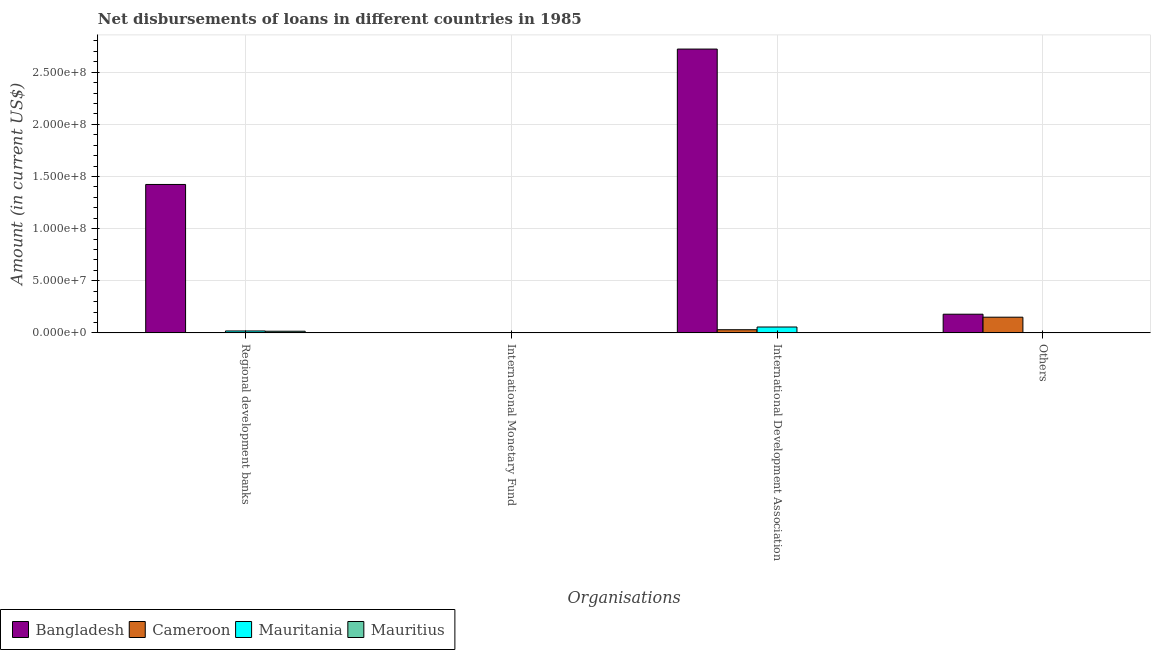How many different coloured bars are there?
Offer a very short reply. 4. Are the number of bars per tick equal to the number of legend labels?
Ensure brevity in your answer.  No. Are the number of bars on each tick of the X-axis equal?
Provide a short and direct response. No. What is the label of the 3rd group of bars from the left?
Offer a very short reply. International Development Association. What is the amount of loan disimbursed by international monetary fund in Mauritius?
Offer a very short reply. 0. Across all countries, what is the maximum amount of loan disimbursed by other organisations?
Your response must be concise. 1.79e+07. What is the total amount of loan disimbursed by international development association in the graph?
Your answer should be compact. 2.81e+08. What is the difference between the amount of loan disimbursed by regional development banks in Cameroon and that in Mauritania?
Your answer should be very brief. -1.83e+06. What is the difference between the amount of loan disimbursed by international monetary fund in Bangladesh and the amount of loan disimbursed by international development association in Mauritania?
Provide a succinct answer. -5.62e+06. What is the average amount of loan disimbursed by other organisations per country?
Provide a succinct answer. 8.23e+06. What is the difference between the amount of loan disimbursed by international development association and amount of loan disimbursed by regional development banks in Bangladesh?
Your answer should be very brief. 1.30e+08. What is the ratio of the amount of loan disimbursed by regional development banks in Cameroon to that in Mauritius?
Make the answer very short. 0. Is the amount of loan disimbursed by regional development banks in Bangladesh less than that in Mauritania?
Offer a very short reply. No. What is the difference between the highest and the second highest amount of loan disimbursed by regional development banks?
Provide a short and direct response. 1.41e+08. What is the difference between the highest and the lowest amount of loan disimbursed by regional development banks?
Give a very brief answer. 1.42e+08. Is it the case that in every country, the sum of the amount of loan disimbursed by regional development banks and amount of loan disimbursed by international monetary fund is greater than the amount of loan disimbursed by international development association?
Give a very brief answer. No. Are all the bars in the graph horizontal?
Your response must be concise. No. What is the difference between two consecutive major ticks on the Y-axis?
Give a very brief answer. 5.00e+07. Does the graph contain any zero values?
Your answer should be very brief. Yes. Does the graph contain grids?
Your answer should be compact. Yes. Where does the legend appear in the graph?
Your answer should be very brief. Bottom left. How many legend labels are there?
Make the answer very short. 4. How are the legend labels stacked?
Your answer should be compact. Horizontal. What is the title of the graph?
Provide a succinct answer. Net disbursements of loans in different countries in 1985. Does "Bulgaria" appear as one of the legend labels in the graph?
Your answer should be very brief. No. What is the label or title of the X-axis?
Your answer should be compact. Organisations. What is the label or title of the Y-axis?
Keep it short and to the point. Amount (in current US$). What is the Amount (in current US$) in Bangladesh in Regional development banks?
Offer a very short reply. 1.42e+08. What is the Amount (in current US$) in Cameroon in Regional development banks?
Your answer should be compact. 5000. What is the Amount (in current US$) of Mauritania in Regional development banks?
Your response must be concise. 1.83e+06. What is the Amount (in current US$) in Mauritius in Regional development banks?
Provide a succinct answer. 1.57e+06. What is the Amount (in current US$) in Bangladesh in International Development Association?
Make the answer very short. 2.72e+08. What is the Amount (in current US$) of Cameroon in International Development Association?
Make the answer very short. 3.02e+06. What is the Amount (in current US$) in Mauritania in International Development Association?
Offer a very short reply. 5.62e+06. What is the Amount (in current US$) in Bangladesh in Others?
Keep it short and to the point. 1.79e+07. What is the Amount (in current US$) in Cameroon in Others?
Keep it short and to the point. 1.50e+07. What is the Amount (in current US$) of Mauritius in Others?
Offer a very short reply. 0. Across all Organisations, what is the maximum Amount (in current US$) in Bangladesh?
Make the answer very short. 2.72e+08. Across all Organisations, what is the maximum Amount (in current US$) in Cameroon?
Give a very brief answer. 1.50e+07. Across all Organisations, what is the maximum Amount (in current US$) of Mauritania?
Provide a short and direct response. 5.62e+06. Across all Organisations, what is the maximum Amount (in current US$) in Mauritius?
Keep it short and to the point. 1.57e+06. Across all Organisations, what is the minimum Amount (in current US$) of Bangladesh?
Your answer should be compact. 0. Across all Organisations, what is the minimum Amount (in current US$) of Mauritius?
Offer a terse response. 0. What is the total Amount (in current US$) in Bangladesh in the graph?
Make the answer very short. 4.32e+08. What is the total Amount (in current US$) of Cameroon in the graph?
Keep it short and to the point. 1.81e+07. What is the total Amount (in current US$) of Mauritania in the graph?
Your answer should be compact. 7.45e+06. What is the total Amount (in current US$) of Mauritius in the graph?
Provide a succinct answer. 1.57e+06. What is the difference between the Amount (in current US$) in Bangladesh in Regional development banks and that in International Development Association?
Your response must be concise. -1.30e+08. What is the difference between the Amount (in current US$) of Cameroon in Regional development banks and that in International Development Association?
Your response must be concise. -3.01e+06. What is the difference between the Amount (in current US$) in Mauritania in Regional development banks and that in International Development Association?
Your answer should be compact. -3.78e+06. What is the difference between the Amount (in current US$) of Bangladesh in Regional development banks and that in Others?
Give a very brief answer. 1.24e+08. What is the difference between the Amount (in current US$) in Cameroon in Regional development banks and that in Others?
Provide a succinct answer. -1.50e+07. What is the difference between the Amount (in current US$) in Bangladesh in International Development Association and that in Others?
Provide a short and direct response. 2.54e+08. What is the difference between the Amount (in current US$) in Cameroon in International Development Association and that in Others?
Offer a very short reply. -1.20e+07. What is the difference between the Amount (in current US$) in Bangladesh in Regional development banks and the Amount (in current US$) in Cameroon in International Development Association?
Give a very brief answer. 1.39e+08. What is the difference between the Amount (in current US$) in Bangladesh in Regional development banks and the Amount (in current US$) in Mauritania in International Development Association?
Provide a succinct answer. 1.37e+08. What is the difference between the Amount (in current US$) of Cameroon in Regional development banks and the Amount (in current US$) of Mauritania in International Development Association?
Make the answer very short. -5.61e+06. What is the difference between the Amount (in current US$) of Bangladesh in Regional development banks and the Amount (in current US$) of Cameroon in Others?
Give a very brief answer. 1.27e+08. What is the difference between the Amount (in current US$) in Bangladesh in International Development Association and the Amount (in current US$) in Cameroon in Others?
Ensure brevity in your answer.  2.57e+08. What is the average Amount (in current US$) in Bangladesh per Organisations?
Your answer should be very brief. 1.08e+08. What is the average Amount (in current US$) of Cameroon per Organisations?
Your answer should be very brief. 4.51e+06. What is the average Amount (in current US$) of Mauritania per Organisations?
Provide a short and direct response. 1.86e+06. What is the average Amount (in current US$) of Mauritius per Organisations?
Your answer should be very brief. 3.92e+05. What is the difference between the Amount (in current US$) of Bangladesh and Amount (in current US$) of Cameroon in Regional development banks?
Give a very brief answer. 1.42e+08. What is the difference between the Amount (in current US$) in Bangladesh and Amount (in current US$) in Mauritania in Regional development banks?
Keep it short and to the point. 1.41e+08. What is the difference between the Amount (in current US$) of Bangladesh and Amount (in current US$) of Mauritius in Regional development banks?
Ensure brevity in your answer.  1.41e+08. What is the difference between the Amount (in current US$) in Cameroon and Amount (in current US$) in Mauritania in Regional development banks?
Provide a short and direct response. -1.83e+06. What is the difference between the Amount (in current US$) of Cameroon and Amount (in current US$) of Mauritius in Regional development banks?
Make the answer very short. -1.56e+06. What is the difference between the Amount (in current US$) of Mauritania and Amount (in current US$) of Mauritius in Regional development banks?
Give a very brief answer. 2.65e+05. What is the difference between the Amount (in current US$) of Bangladesh and Amount (in current US$) of Cameroon in International Development Association?
Keep it short and to the point. 2.69e+08. What is the difference between the Amount (in current US$) in Bangladesh and Amount (in current US$) in Mauritania in International Development Association?
Provide a short and direct response. 2.67e+08. What is the difference between the Amount (in current US$) in Cameroon and Amount (in current US$) in Mauritania in International Development Association?
Keep it short and to the point. -2.60e+06. What is the difference between the Amount (in current US$) of Bangladesh and Amount (in current US$) of Cameroon in Others?
Your response must be concise. 2.86e+06. What is the ratio of the Amount (in current US$) in Bangladesh in Regional development banks to that in International Development Association?
Your response must be concise. 0.52. What is the ratio of the Amount (in current US$) in Cameroon in Regional development banks to that in International Development Association?
Your answer should be very brief. 0. What is the ratio of the Amount (in current US$) in Mauritania in Regional development banks to that in International Development Association?
Your answer should be very brief. 0.33. What is the ratio of the Amount (in current US$) of Bangladesh in Regional development banks to that in Others?
Offer a very short reply. 7.96. What is the ratio of the Amount (in current US$) of Bangladesh in International Development Association to that in Others?
Your answer should be very brief. 15.22. What is the ratio of the Amount (in current US$) of Cameroon in International Development Association to that in Others?
Make the answer very short. 0.2. What is the difference between the highest and the second highest Amount (in current US$) in Bangladesh?
Your response must be concise. 1.30e+08. What is the difference between the highest and the second highest Amount (in current US$) in Cameroon?
Keep it short and to the point. 1.20e+07. What is the difference between the highest and the lowest Amount (in current US$) in Bangladesh?
Give a very brief answer. 2.72e+08. What is the difference between the highest and the lowest Amount (in current US$) in Cameroon?
Provide a succinct answer. 1.50e+07. What is the difference between the highest and the lowest Amount (in current US$) of Mauritania?
Give a very brief answer. 5.62e+06. What is the difference between the highest and the lowest Amount (in current US$) in Mauritius?
Provide a succinct answer. 1.57e+06. 